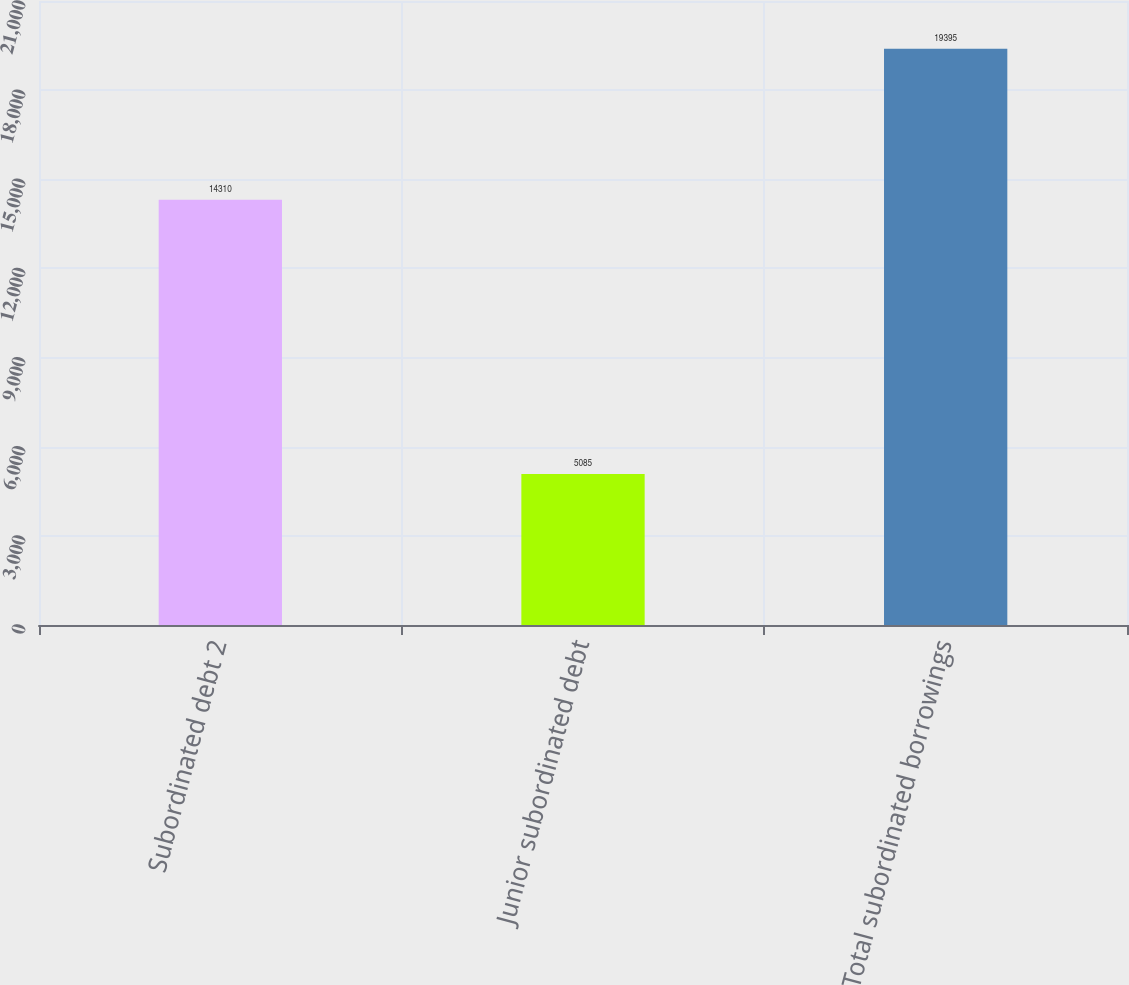Convert chart to OTSL. <chart><loc_0><loc_0><loc_500><loc_500><bar_chart><fcel>Subordinated debt 2<fcel>Junior subordinated debt<fcel>Total subordinated borrowings<nl><fcel>14310<fcel>5085<fcel>19395<nl></chart> 